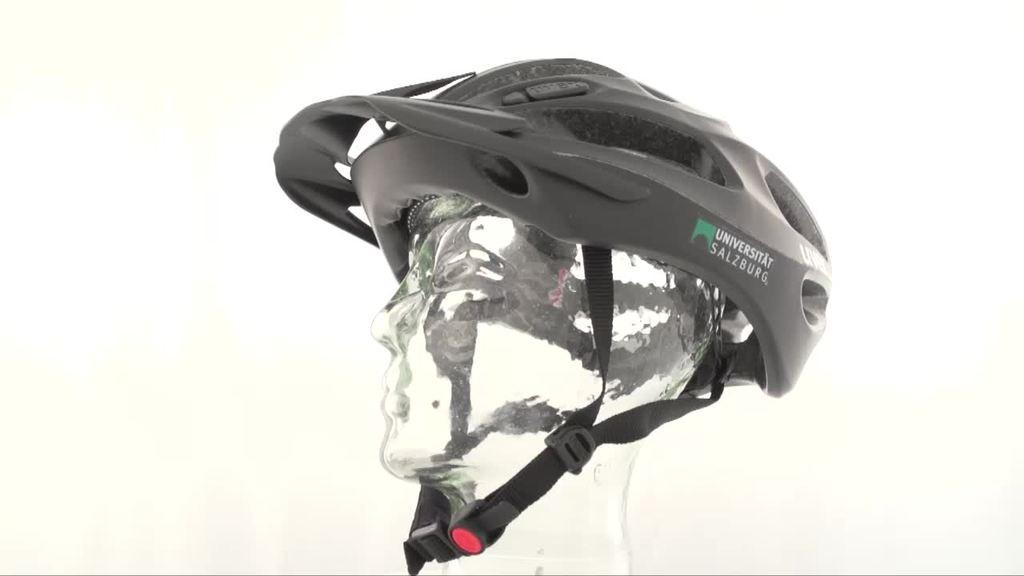What is the main subject of the image? The main subject of the image is a mannequin. What is the mannequin made of? The mannequin is made of ice. What is on top of the mannequin? There is a helmet on top of the mannequin. What type of school can be seen in the image? There is no school present in the image; it features a mannequin made of ice with a helmet on top. How many rings are visible on the mannequin's fingers in the image? There are no rings visible on the mannequin's fingers in the image, as it is made of ice and does not have fingers. 